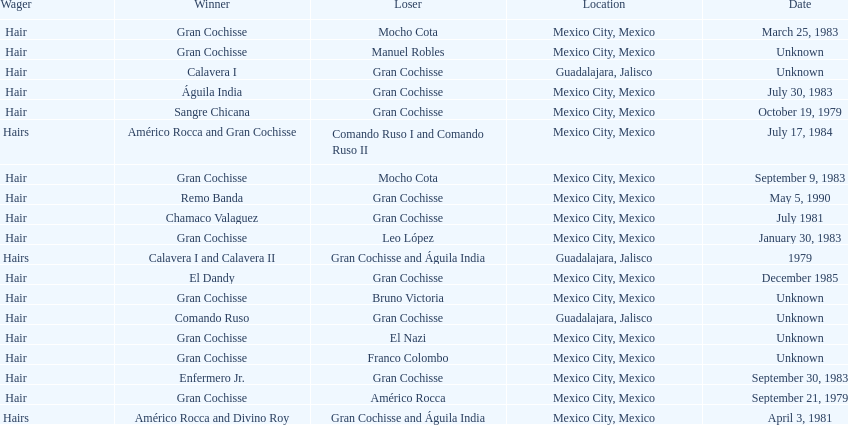What was the number of losses gran cochisse had against el dandy? 1. 